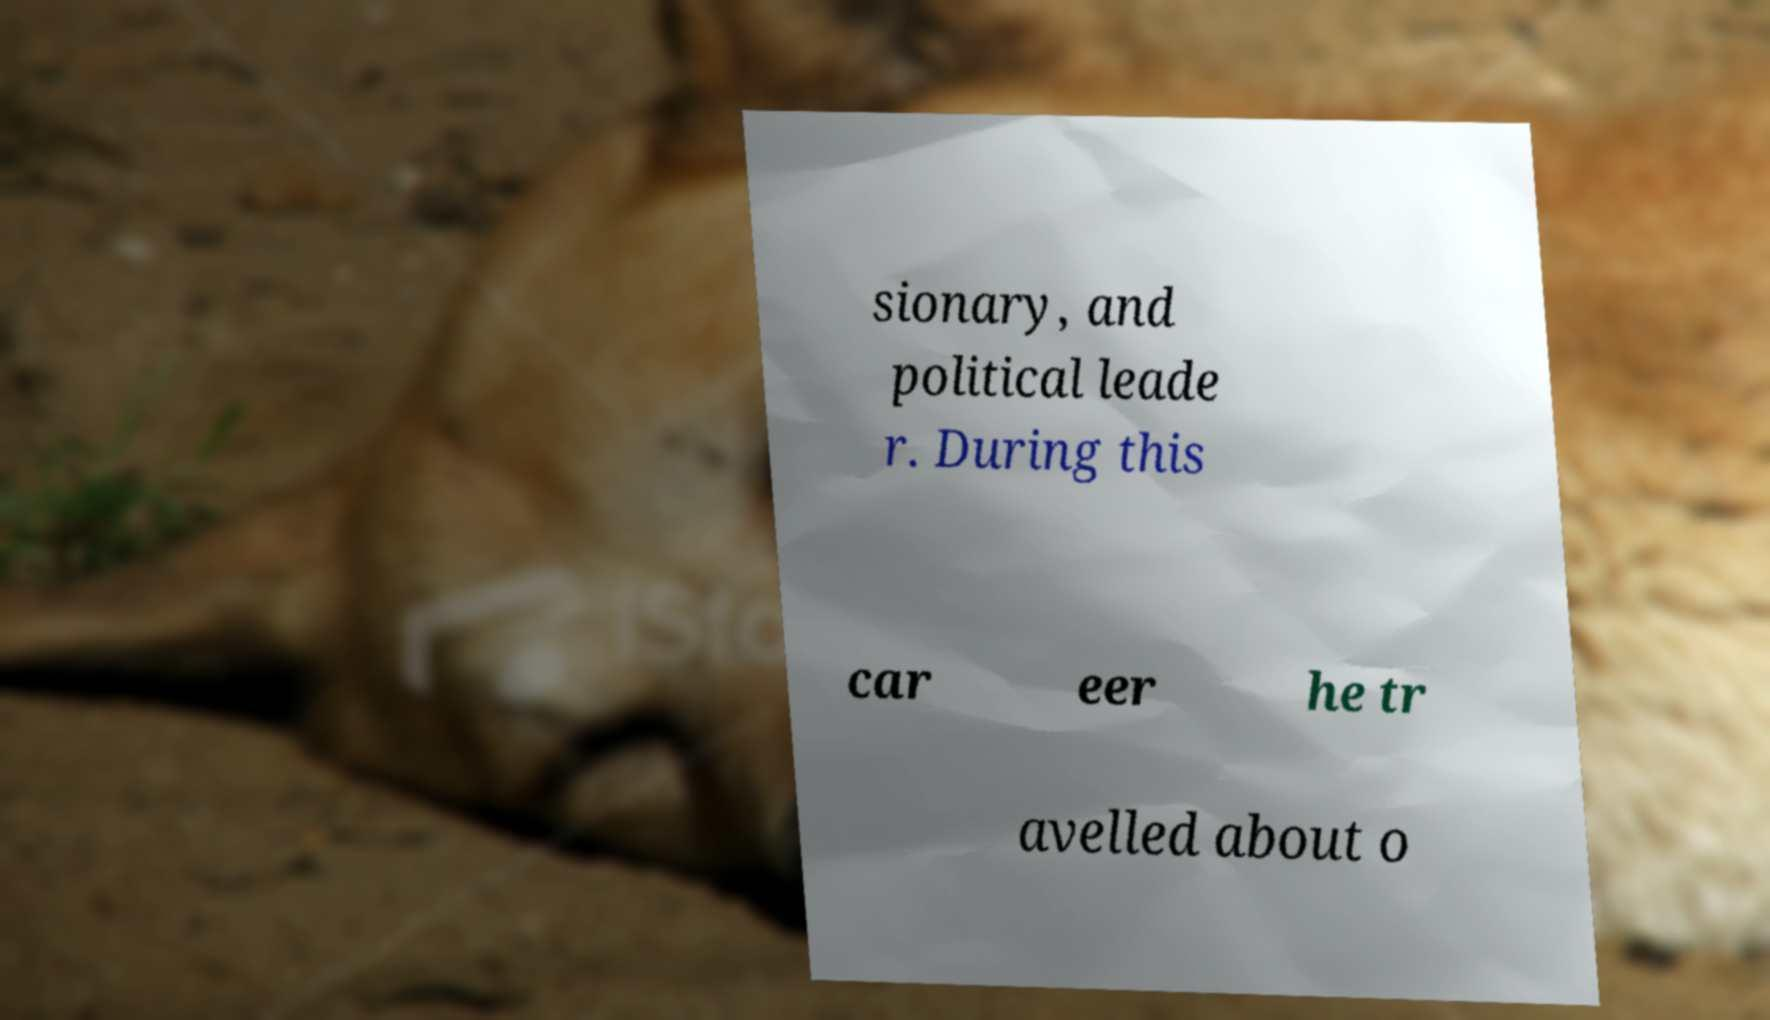For documentation purposes, I need the text within this image transcribed. Could you provide that? sionary, and political leade r. During this car eer he tr avelled about o 